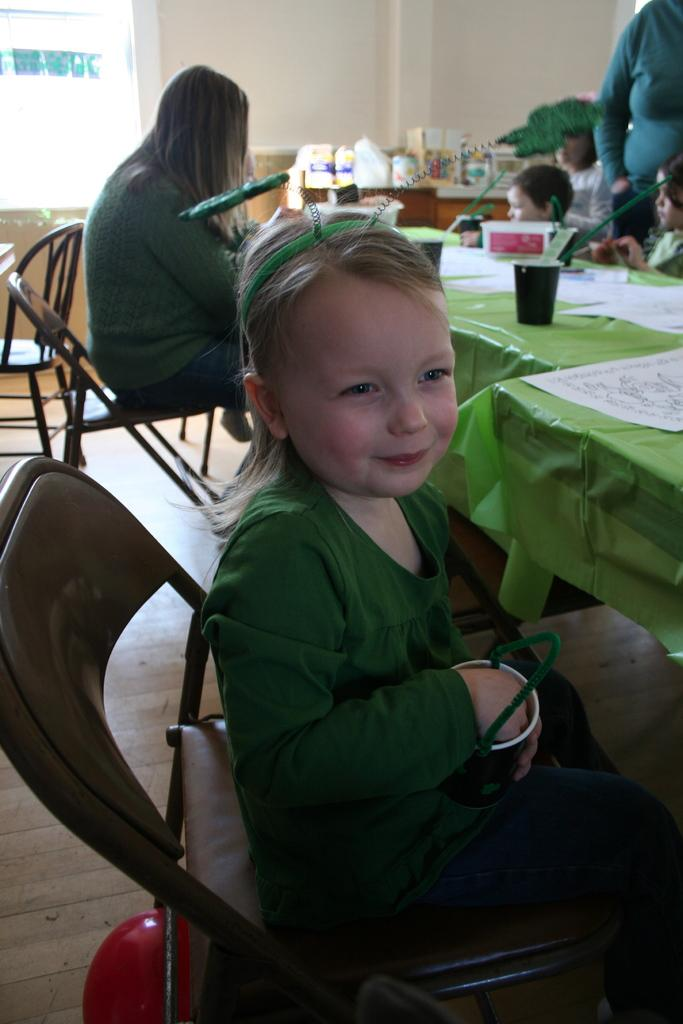What is the girl in the image doing? The girl is sitting in a chair at a table in the image. What is the girl wearing? The girl is wearing a green costume. Who is sitting behind the girl? There is a woman sitting behind the girl in a chair. Can you describe the setting in the background? A few children are sitting at a distance in the background. What type of lamp is on the table next to the girl? There is no lamp present on the table next to the girl in the image. 